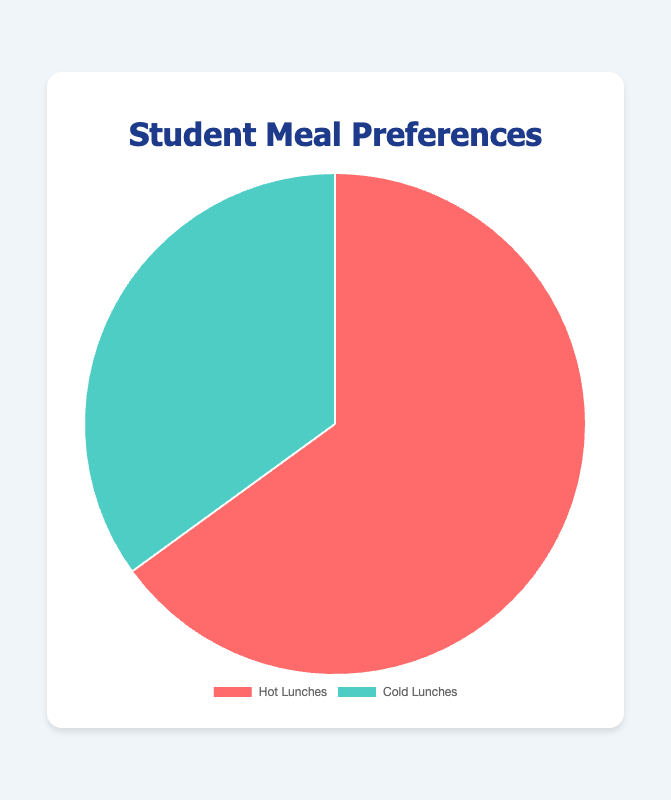what percentage of students prefer hot lunches? Looking at the pie chart, the segment for hot lunches shows a percentage of 65. Therefore, 65% of students prefer hot lunches.
Answer: 65% What type of lunch is less preferred among students? Comparing the pie chart segments, hot lunches have a larger share (65%) than cold lunches (35%). Therefore, cold lunches are less preferred.
Answer: Cold lunches How much more popular is hot lunch compared to cold lunch? The percentage of students preferring hot lunches is 65%, and for cold lunches, it's 35%. The difference is 65 - 35 = 30.
Answer: 30% What is the ratio of students preferring hot lunches to those preferring cold lunches? The percentage for hot lunches is 65%, and for cold lunches, it is 35%. Hence, the ratio is 65:35, which simplifies to 13:7.
Answer: 13:7 What is the combined percentage of students who prefer cold and hot lunches? The two segments in the pie chart represent the total preferences: 65% (hot lunches) + 35% (cold lunches) = 100%.
Answer: 100% Between hot and cold lunches, which preference is shown in red color? By referring to the colors displayed in the chart, it is evident that the segment for hot lunches is depicted in red.
Answer: Hot lunches If another school had 70% of students preferring hot lunches, how would that compare to our school’s data? In our school, the percentage for hot lunches is 65%. Another school's 70% is higher than our 65% by comparing these values directly.
Answer: 70% If out of 1000 students, how many prefer cold lunches based on the chart data? To compute the number of students preferring cold lunches, take 35% of 1000. This can be calculated as 1000 * 0.35 = 350 students.
Answer: 350 students If the percentage of students who preferred hot lunches increased by 5%, what would the new percentage be? Currently, 65% prefer hot lunches. Adding 5% to this, the new percentage would be 65 + 5 = 70%.
Answer: 70% 